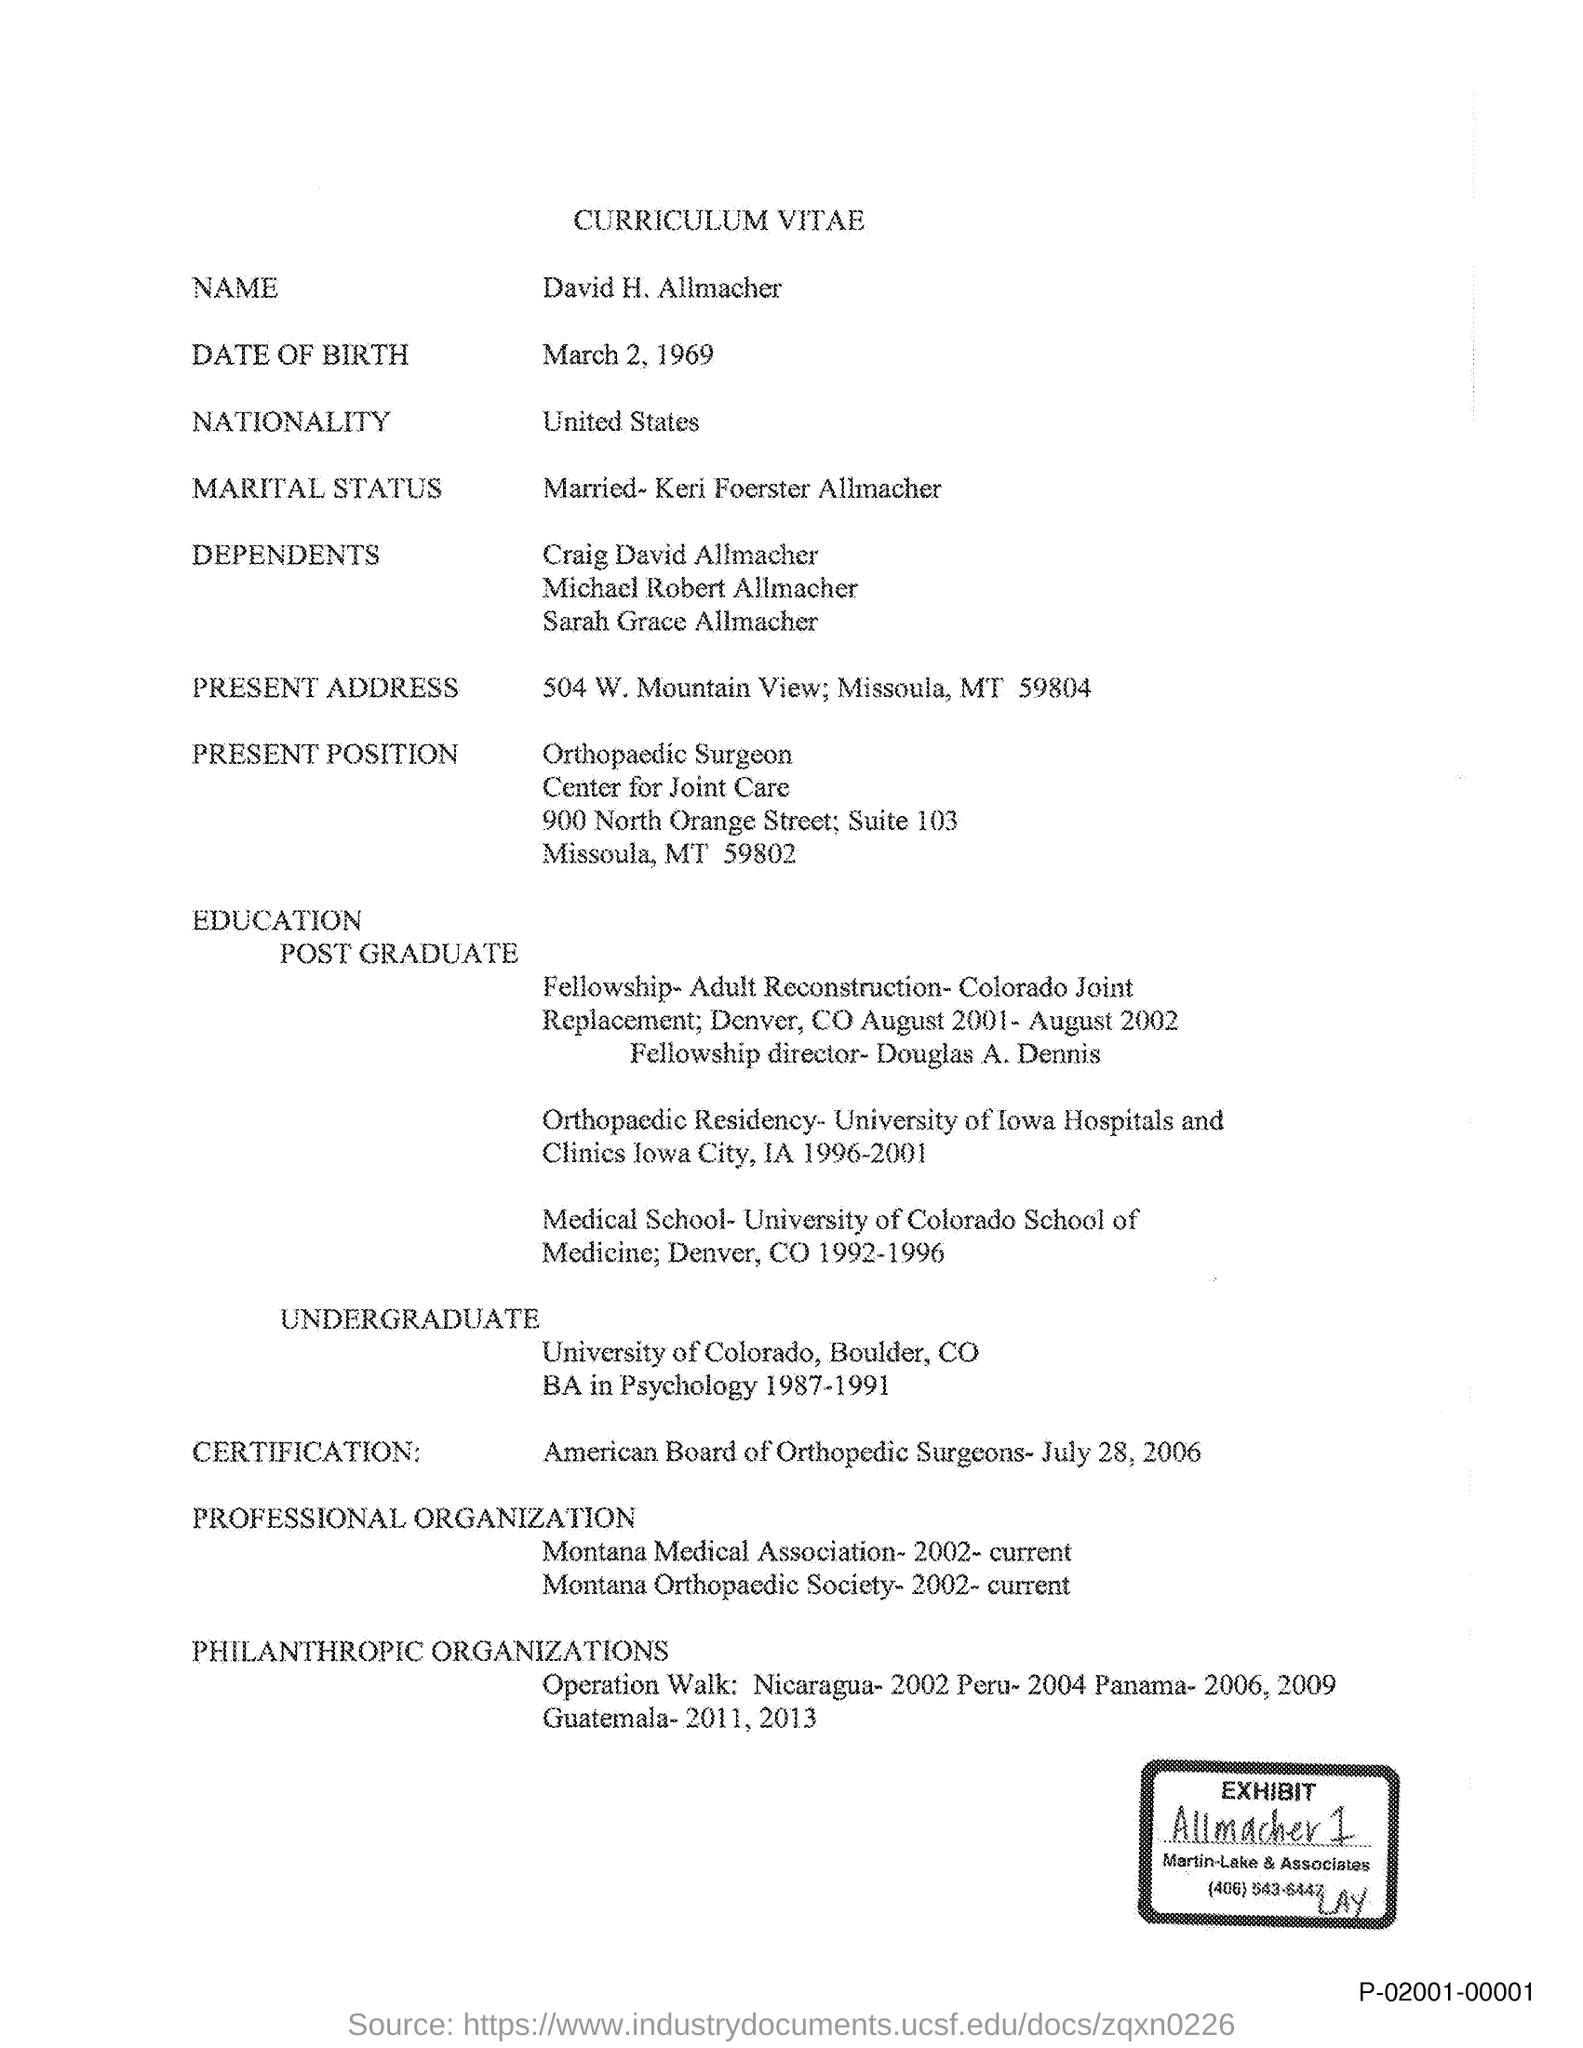Who's curriculum vitae is given here?
Ensure brevity in your answer.  David H. Allmacher. What is the nationality of David H. Allmacher?
Your response must be concise. United States. During which year, David H. Allmacher did BA degree in Psychology?
Ensure brevity in your answer.  1987-1991. 